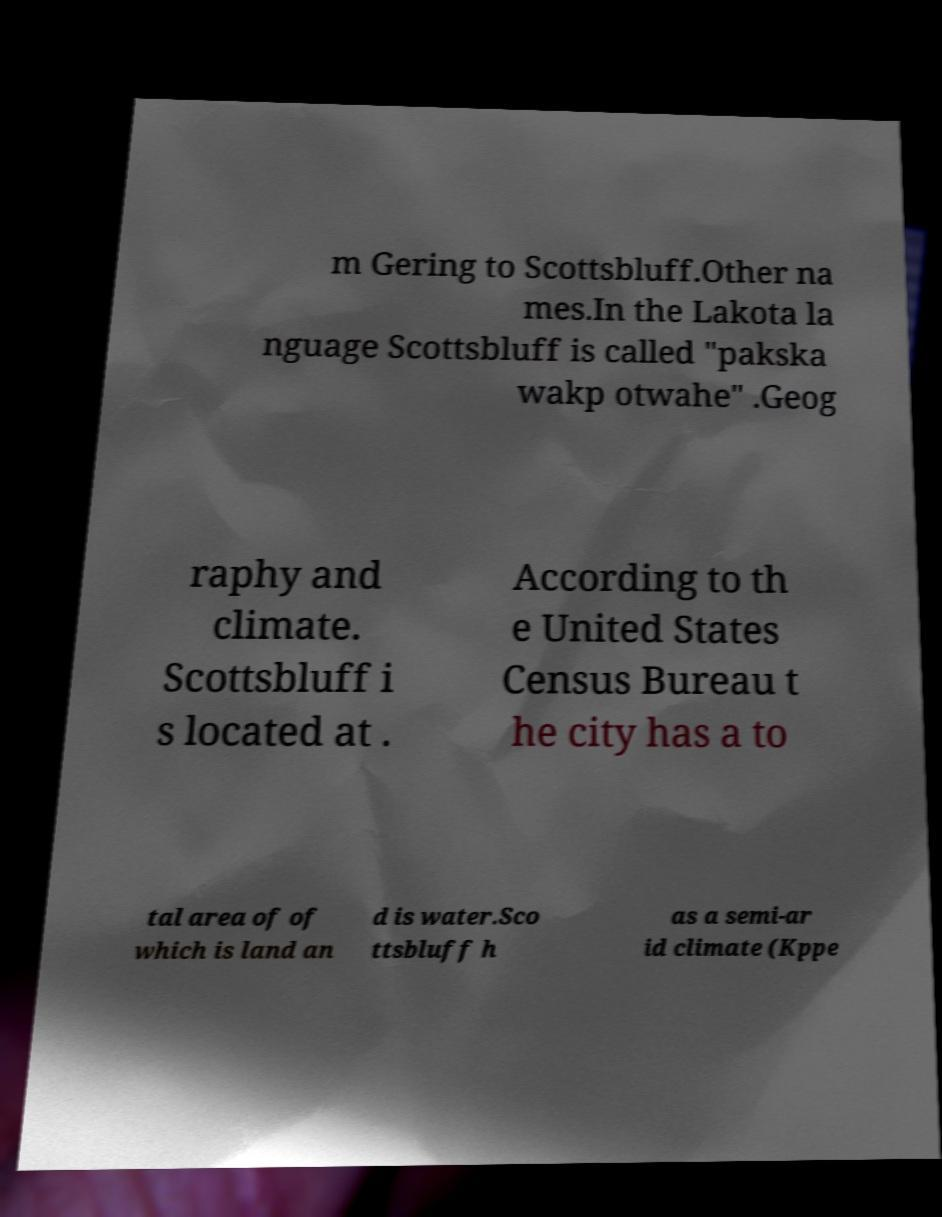There's text embedded in this image that I need extracted. Can you transcribe it verbatim? m Gering to Scottsbluff.Other na mes.In the Lakota la nguage Scottsbluff is called "pakska wakp otwahe" .Geog raphy and climate. Scottsbluff i s located at . According to th e United States Census Bureau t he city has a to tal area of of which is land an d is water.Sco ttsbluff h as a semi-ar id climate (Kppe 